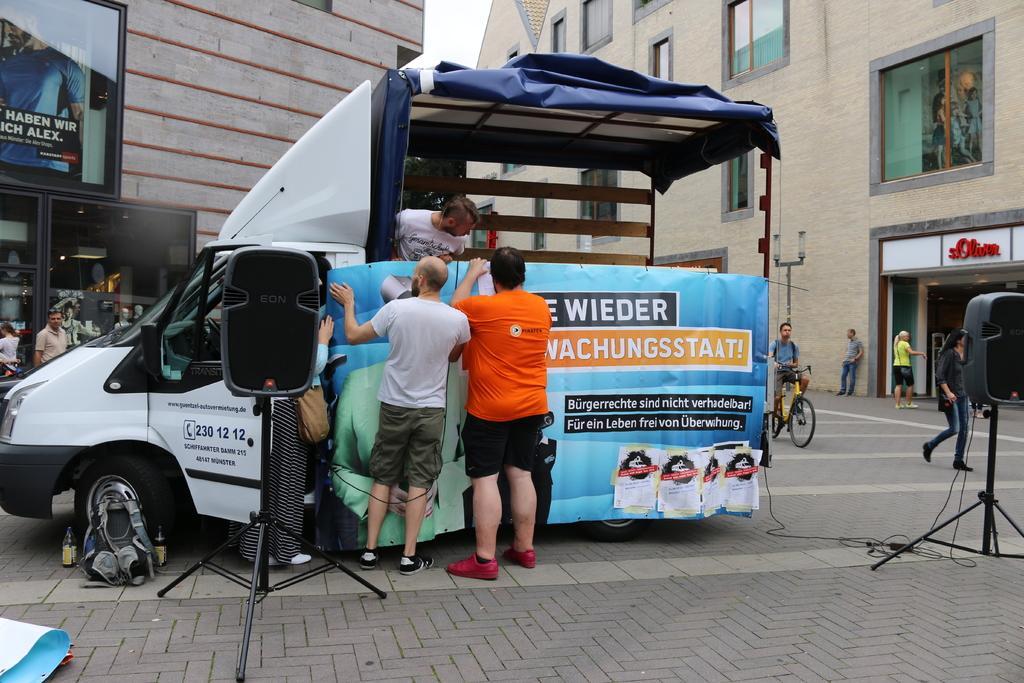Could you give a brief overview of what you see in this image? This is a picture on the streets. In the foreground on the pavement there are two speakers and a vehicle, on the vehicle there is a banner. In the center of the picture there are three person standing. In the background there are buildings and few persons. 